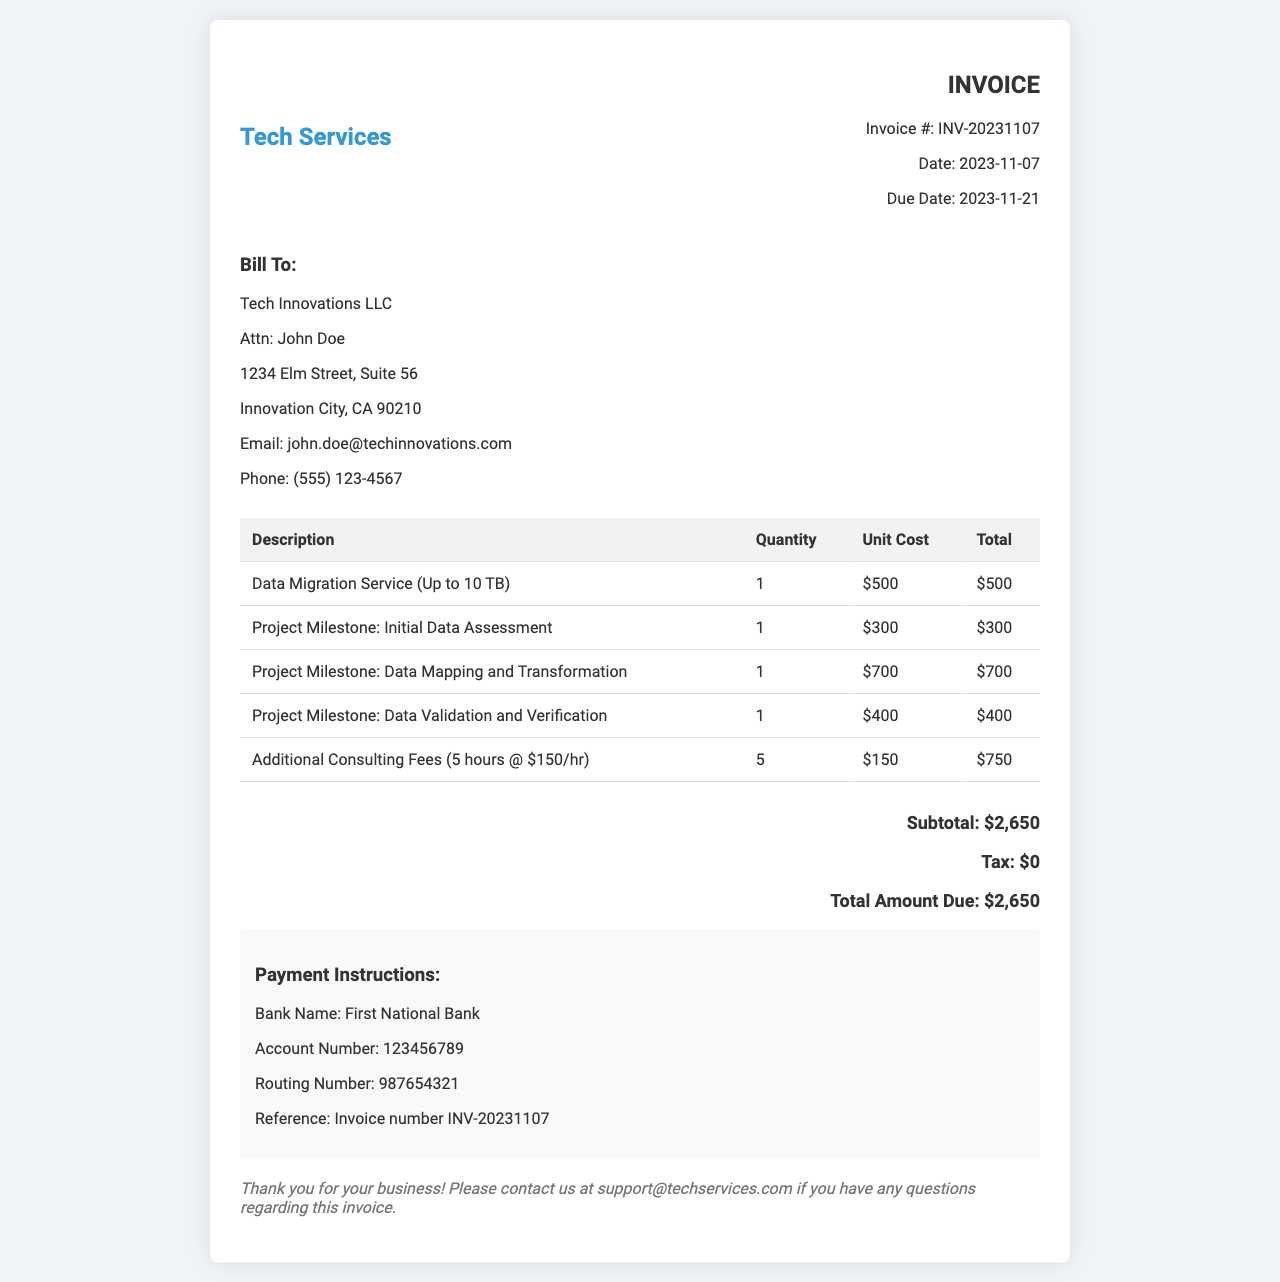What is the invoice number? The invoice number is listed at the top of the document under the invoice details section.
Answer: INV-20231107 What is the total amount due? The total amount due is stated at the bottom of the invoice in the total section.
Answer: $2,650 What is the date of the invoice? The date of the invoice is mentioned in the invoice details section.
Answer: 2023-11-07 How many project milestones are listed? The invoice includes three project milestones, as seen in the detailed list.
Answer: 3 What is the unit cost for additional consulting fees? The unit cost for additional consulting is provided in the line item for consulting fees.
Answer: $150 What is the payment due date? The payment due date is mentioned alongside the date of the invoice.
Answer: 2023-11-21 Who is the invoice billed to? The billing information is provided in the bill to section at the top of the invoice.
Answer: Tech Innovations LLC What are the payment instructions? Specific details for payment are included in the payment instructions section of the invoice.
Answer: Bank Name: First National Bank What is the subtotal before tax? The subtotal is itemized in the invoice before tax is applied.
Answer: $2,650 